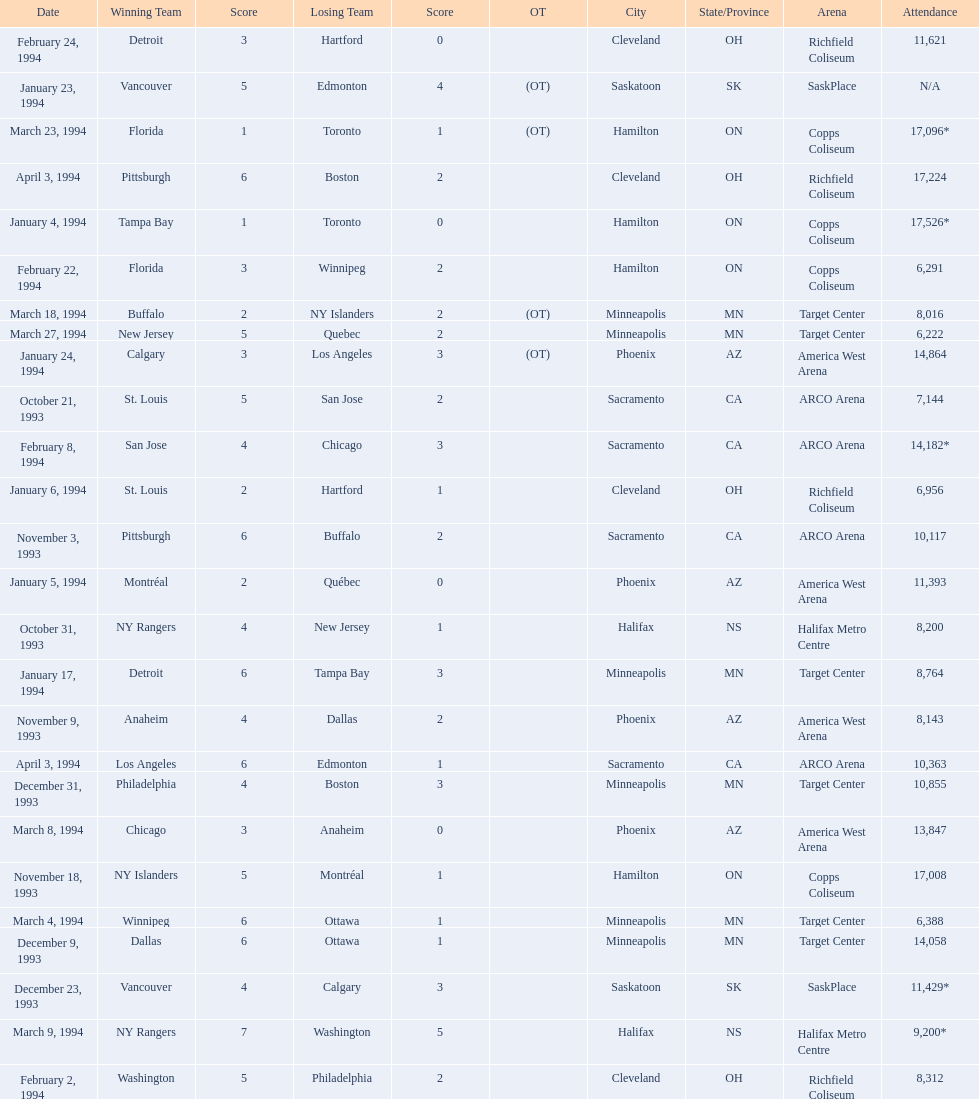What are the attendances of the 1993-94 nhl season? 7,144, 8,200, 10,117, 8,143, 17,008, 14,058, 11,429*, 10,855, 17,526*, 11,393, 6,956, 8,764, N/A, 14,864, 8,312, 14,182*, 6,291, 11,621, 6,388, 13,847, 9,200*, 8,016, 17,096*, 6,222, 17,224, 10,363. Which of these is the highest attendance? 17,526*. Which date did this attendance occur? January 4, 1994. 